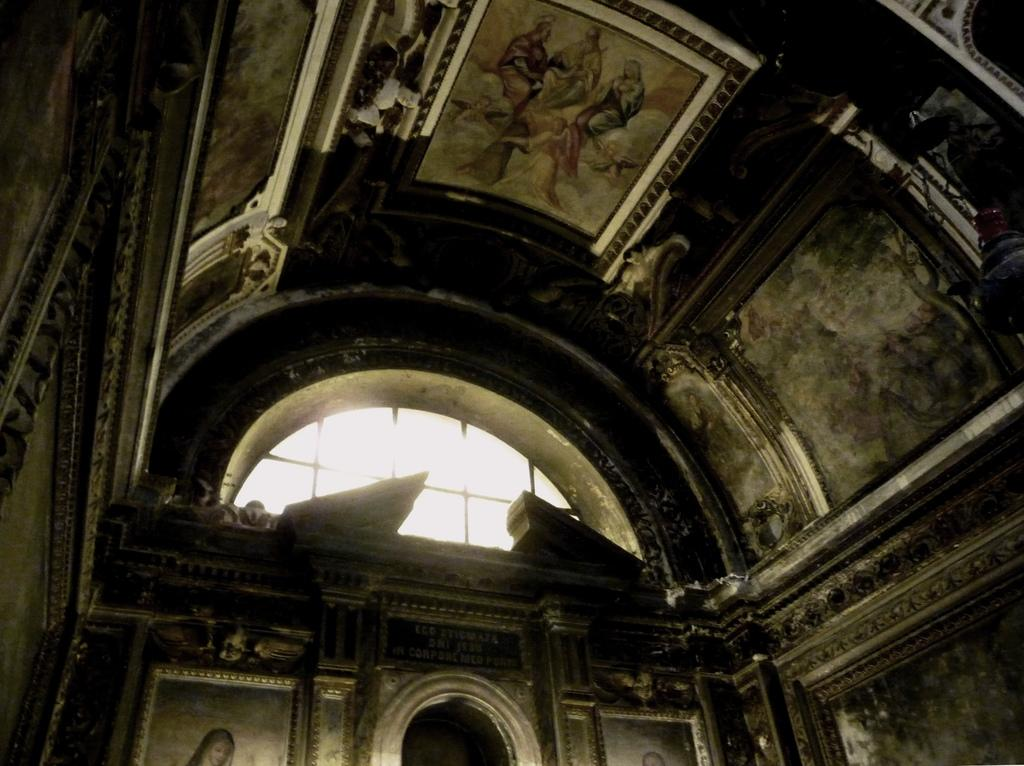What type of location is depicted in the image? The image shows an inner view of a building. What can be seen on the walls and ceiling of the building? The walls and ceiling of the building have different kinds of pictures. Are there any specific architectural features visible in the image? Yes, there are glass ventilators in the image. How many deer can be seen in the image? There are no deer present in the image; it shows an inner view of a building with pictures on the walls and ceiling. What type of umbrella is being used by the person in the image? There is no person or umbrella visible in the image. 